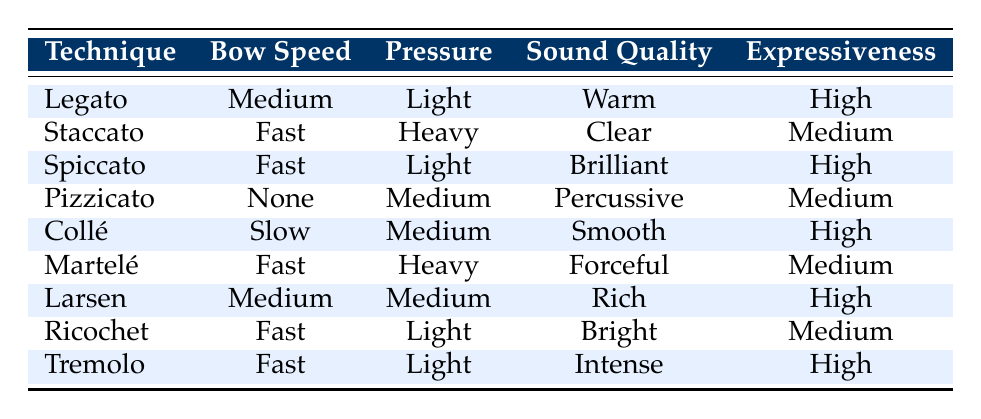What is the sound quality associated with the Legato technique? In the table, the sound quality for the Legato technique is specifically listed in its row under the "Sound Quality" column. It states "Warm" as the sound quality.
Answer: Warm Which technique has the highest expressiveness? To determine this, I need to look through the "Expressiveness" column for all techniques and identify the one marked as "High." The techniques with high expressiveness are Legato, Spiccato, Collé, Larsen, and Tremolo, but I just need to mention one here for the answer.
Answer: Legato True or False: The Staccato technique uses medium pressure. In the Staccato row, the pressure value is listed as "Heavy," meaning the statement about medium pressure is incorrect. Therefore, the answer is False.
Answer: False How many techniques characterized by fast bow speed have high expressiveness? I will examine the "Bow Speed" column for "Fast" and check the corresponding rows to see which of them lists "High" under the "Expressiveness" column. The techniques that fit this criterion are Spiccato and Tremolo, totaling 2.
Answer: 2 What is the average expressiveness level of techniques that have a medium bow speed? The techniques with medium bow speed are Legato and Larsen. Both of these are marked "High" for expressiveness. Since there are two techniques and both are "High," the average expressiveness can be interpreted as High (not a numerical average but an assessment of expressiveness level). Therefore, while no numerical average exists, the level is essentially high since both are "High."
Answer: High How does the sound quality of Pizzicato compare to that of Spiccato? Looking at the rows of Pizzicato and Spiccato, I find that Pizzicato has "Percussive" sound quality, while Spiccato has "Brilliant." Therefore, the comparison indicates that Spiccato's sound quality is more dynamic and bright compared to Pizzicato's percussive style.
Answer: Spiccato is more brilliant What is the sound quality of the Collé technique? I will refer to the "Sound Quality" column in the Collé row, which specifies the sound quality as "Smooth." This directly answers the question.
Answer: Smooth Which technique has the least expressiveness and what is its sound quality? The technique with medium expressiveness is either Staccato, Pizzicato, or Martelé, as they are marked "Medium". By checking their sound qualities in the relevant row, I find that Staccato has "Clear," Pizzicato has "Percussive," and Martelé has "Forceful." Since they all have the same expressiveness level, I will choose the first one listed.
Answer: Staccato, Clear 